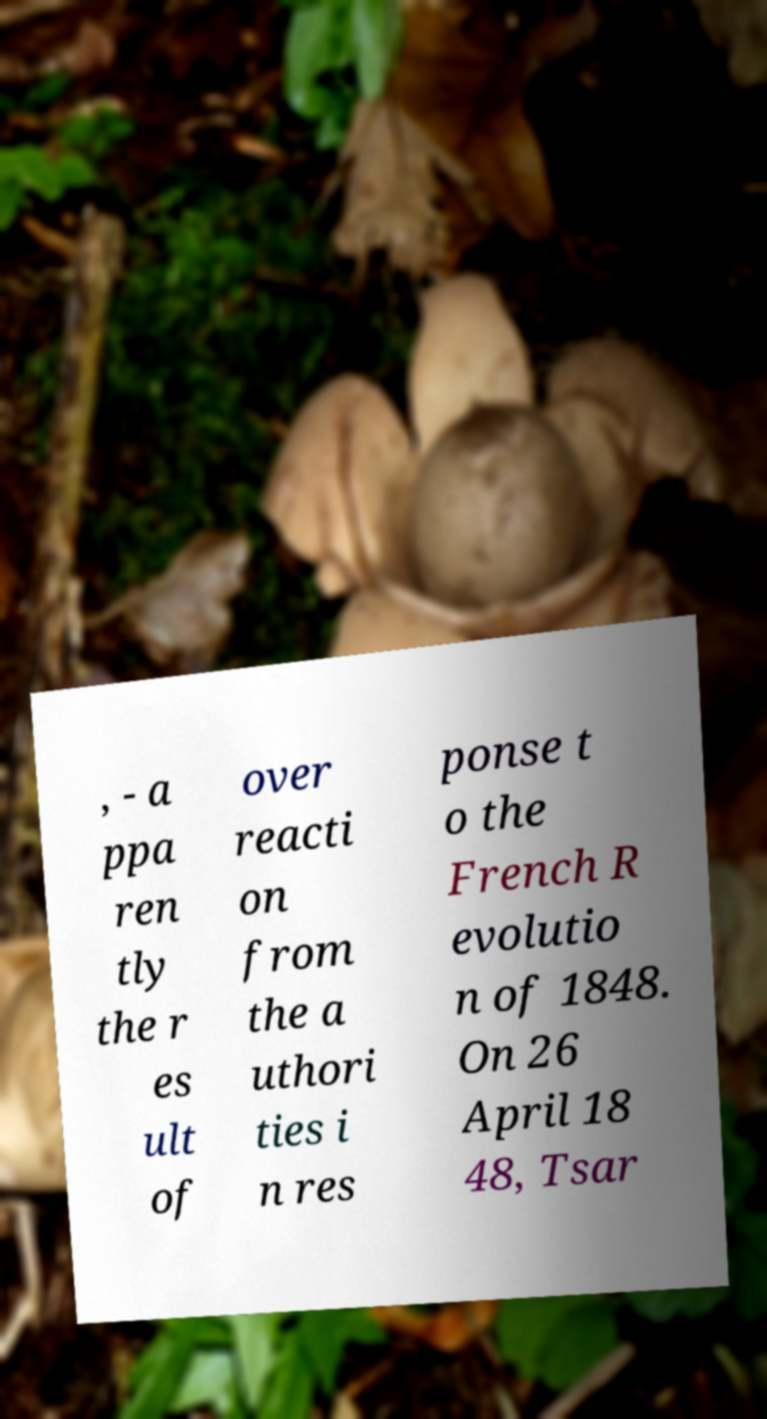For documentation purposes, I need the text within this image transcribed. Could you provide that? , - a ppa ren tly the r es ult of over reacti on from the a uthori ties i n res ponse t o the French R evolutio n of 1848. On 26 April 18 48, Tsar 